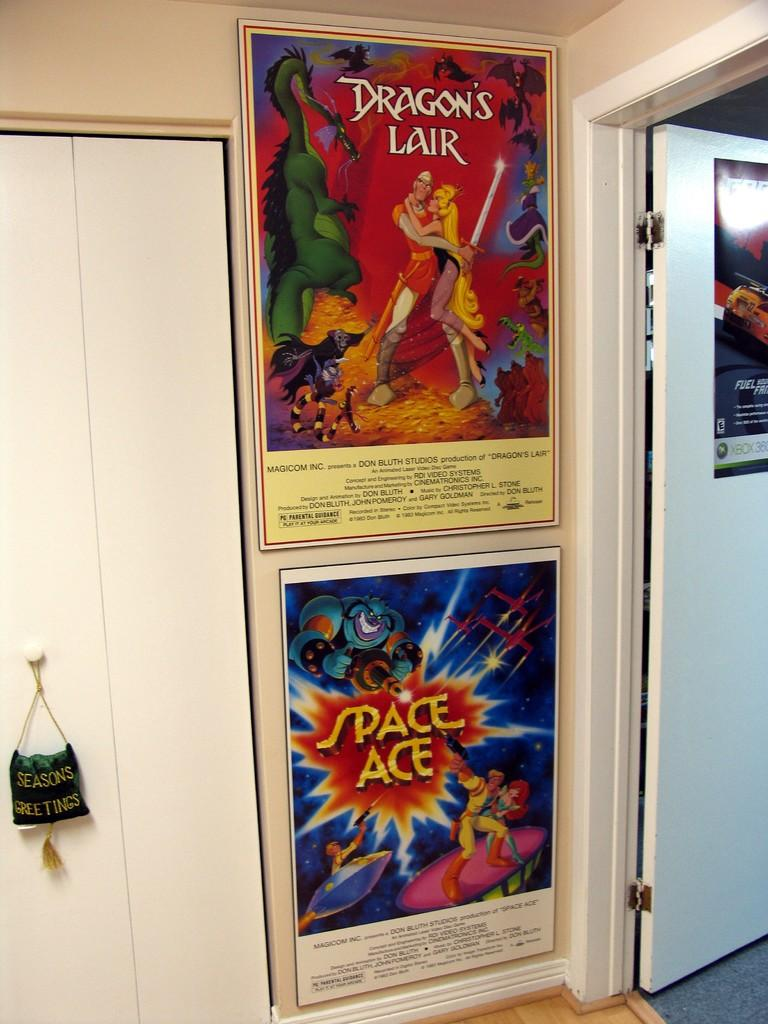<image>
Give a short and clear explanation of the subsequent image. A pair of posters for Dragon's Lair and Space Ace are on a wall. 